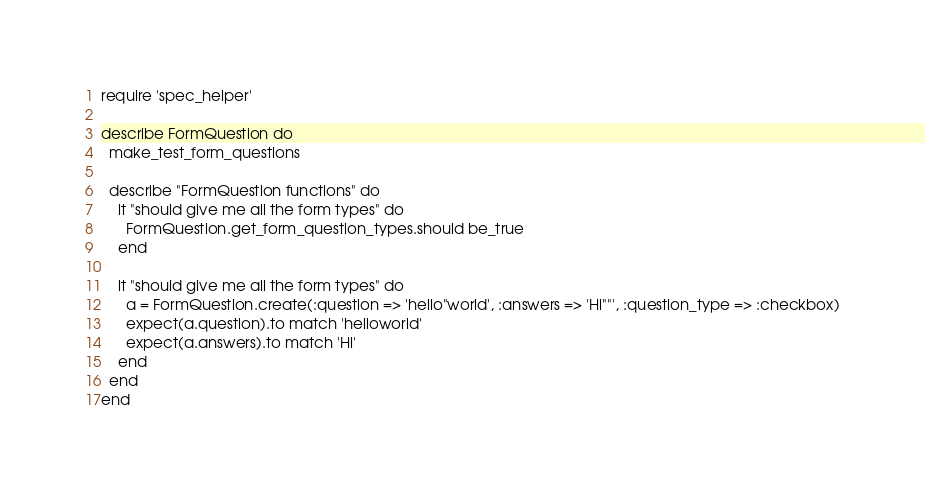Convert code to text. <code><loc_0><loc_0><loc_500><loc_500><_Ruby_>require 'spec_helper'

describe FormQuestion do
  make_test_form_questions
  
  describe "FormQuestion functions" do
    it "should give me all the form types" do
      FormQuestion.get_form_question_types.should be_true
    end
      
    it "should give me all the form types" do
      a = FormQuestion.create(:question => 'hello"world', :answers => 'Hi""', :question_type => :checkbox)
      expect(a.question).to match 'helloworld'
      expect(a.answers).to match 'Hi'
    end
  end
end
</code> 